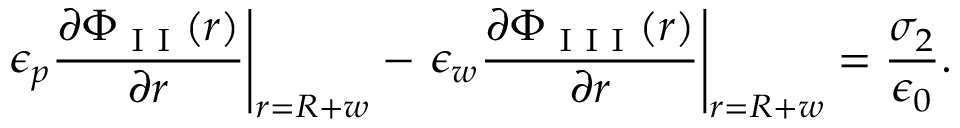<formula> <loc_0><loc_0><loc_500><loc_500>\epsilon _ { p } \frac { \partial \Phi _ { I I } ( r ) } { \partial r } \right | _ { r = R + w } - \epsilon _ { w } \frac { \partial \Phi _ { I I I } ( r ) } { \partial r } \right | _ { r = R + w } = \frac { \sigma _ { 2 } } { \epsilon _ { 0 } } .</formula> 